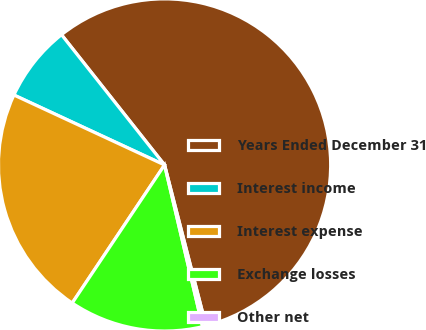Convert chart to OTSL. <chart><loc_0><loc_0><loc_500><loc_500><pie_chart><fcel>Years Ended December 31<fcel>Interest income<fcel>Interest expense<fcel>Exchange losses<fcel>Other net<nl><fcel>56.64%<fcel>7.43%<fcel>22.54%<fcel>13.06%<fcel>0.34%<nl></chart> 